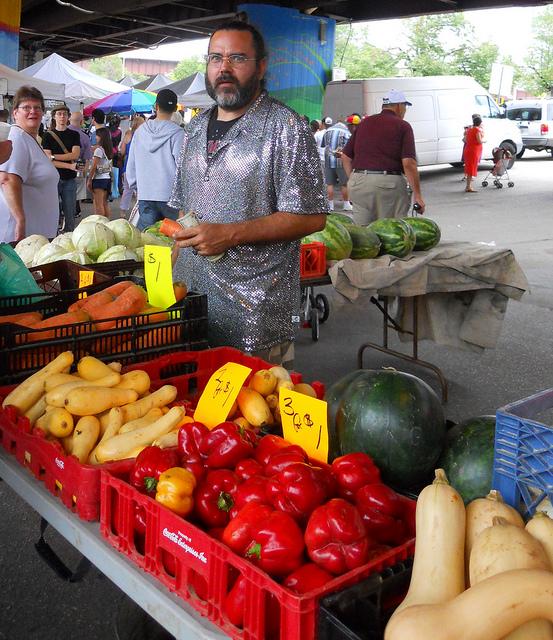Is this an example of an assembly line?
Write a very short answer. No. What are the red vegetables called?
Answer briefly. Peppers. Is the man selling bananas?
Concise answer only. No. Can you see watermelons?
Concise answer only. Yes. What colors are on the umbrella in the background?
Write a very short answer. Rainbow. What color is the cashier's visor?
Concise answer only. No visor. Is this a donut shop?
Write a very short answer. No. What is all over the man's face?
Answer briefly. Beard. How many men are pictured?
Write a very short answer. 1. 